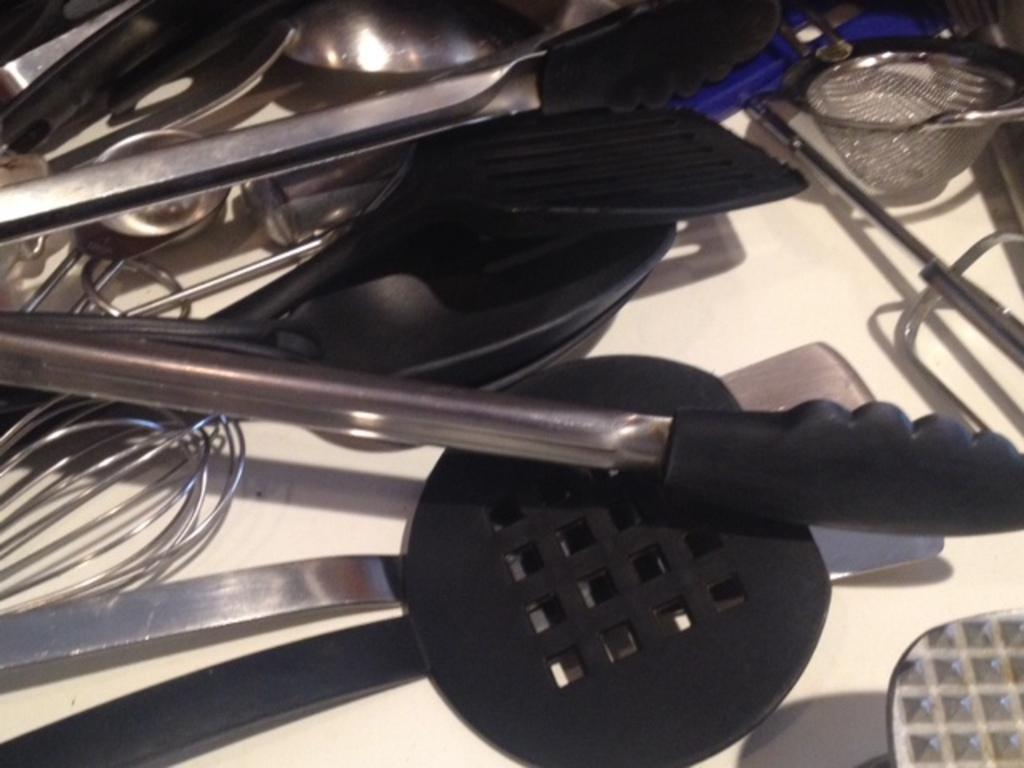What type of utensils can be seen in the image? There are many utensils in the image. Can you describe the specific type of utensils? Yes, there are spoons in the image. What color are the spoons? The spoons are black in color. On what surface are the utensils and spoons placed? The utensils and spoons are on a white surface. What type of sand can be seen in the image? There is no sand present in the image; it features utensils and spoons on a white surface. 